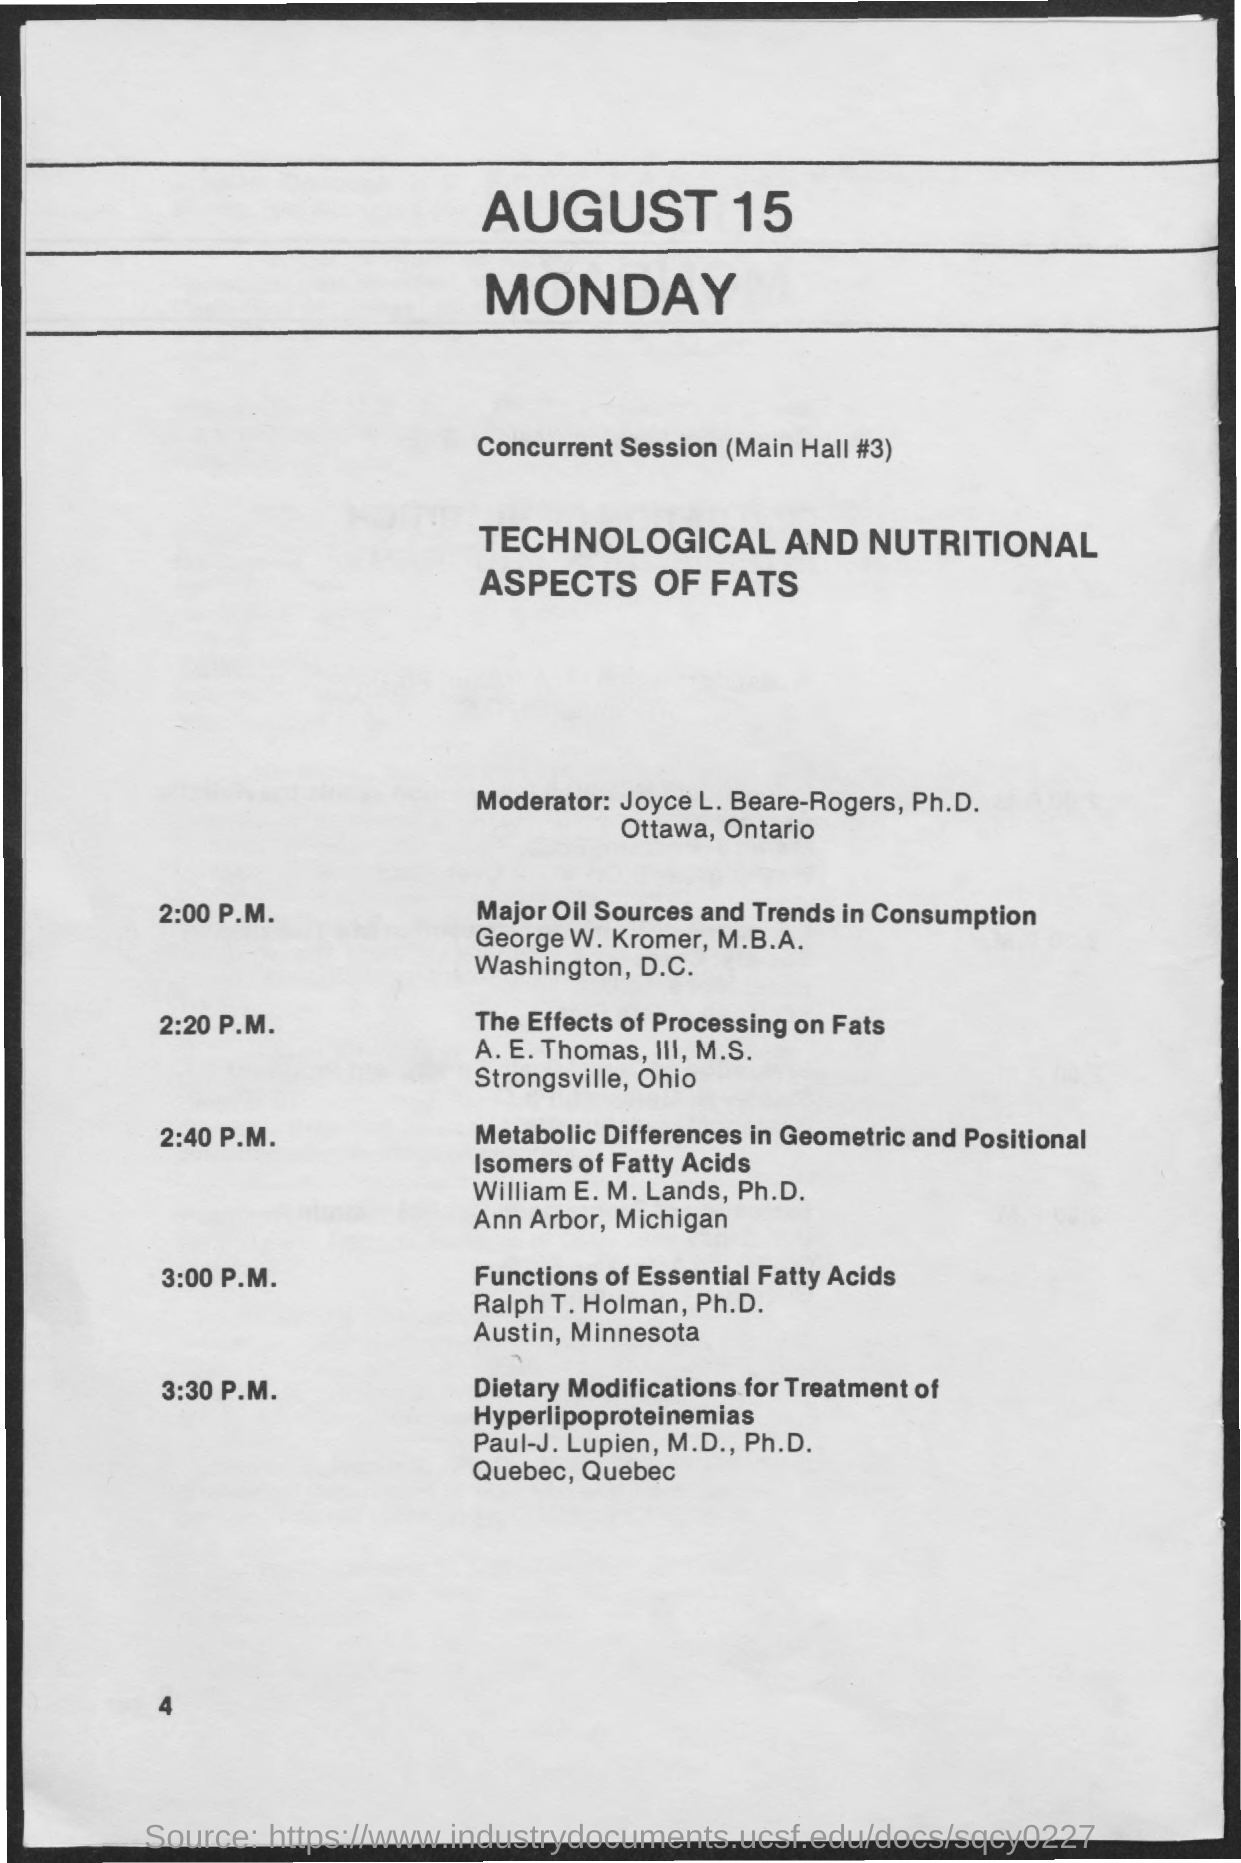What is the page no mentioned in this document?
Provide a short and direct response. 4. Who is the Moderator for the sessions?
Your answer should be very brief. Joyce L. Beare-Rogers. Where is the concurrent session held?
Offer a terse response. Main Hall #3. Who is presenting the session on "The Effects of Processing on Fats"?
Your answer should be compact. A. E. Thomas, III, M.S. What time is the session on "Major oil Sources and Trends in Consumption" held?
Your response must be concise. 2:00 P.M. Who is presenting the session on "Functions of Essential Fatty Acids"?
Keep it short and to the point. Ralph T. Holman, Ph.D. 